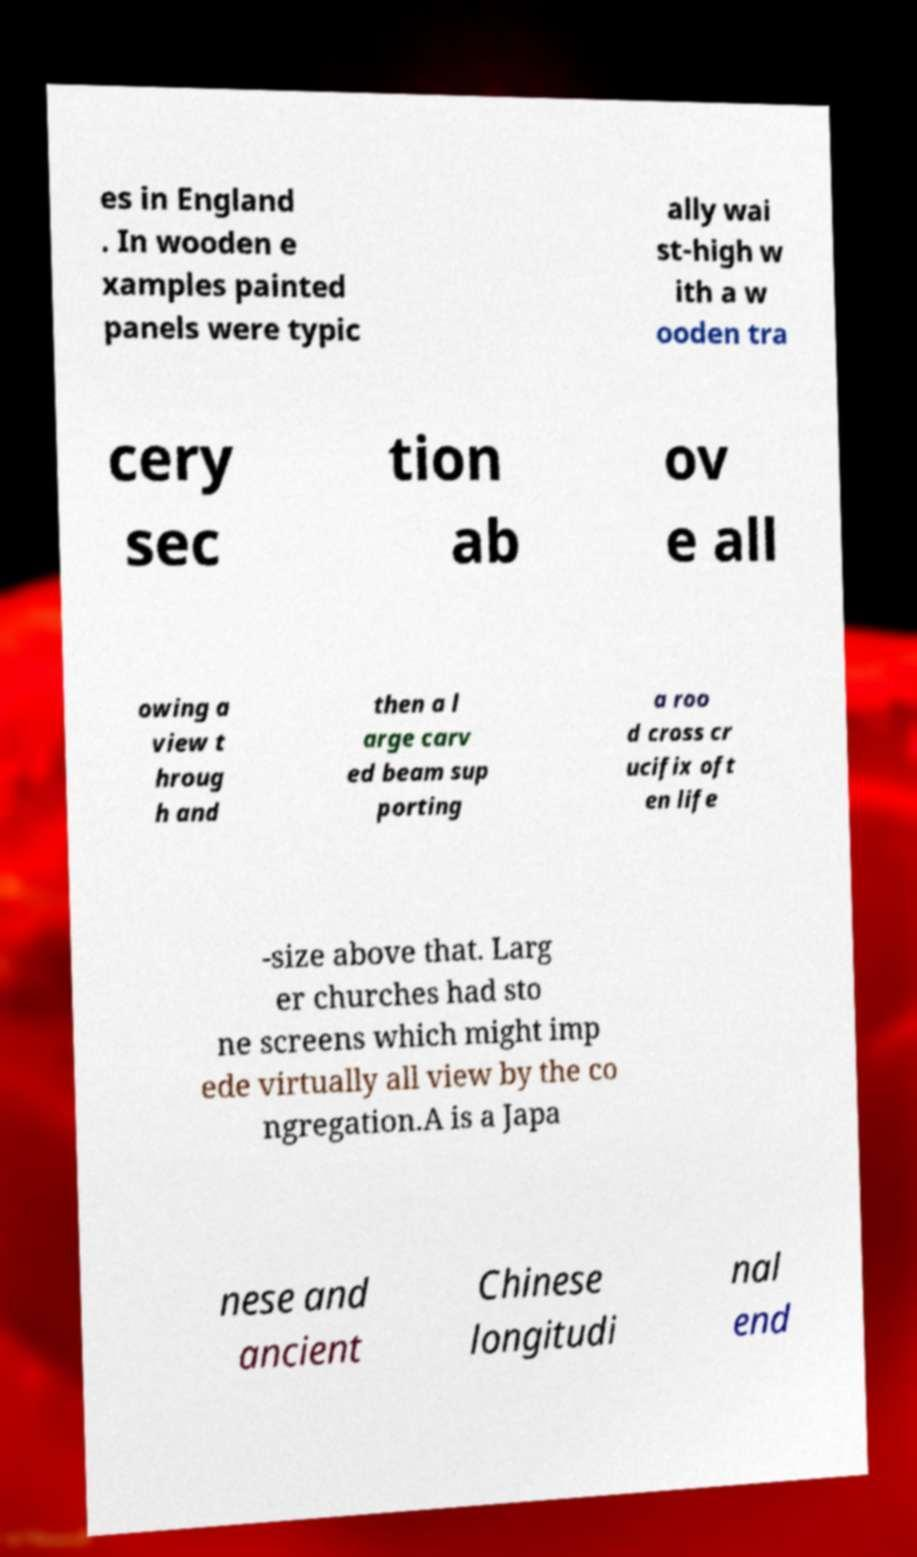Please read and relay the text visible in this image. What does it say? es in England . In wooden e xamples painted panels were typic ally wai st-high w ith a w ooden tra cery sec tion ab ov e all owing a view t hroug h and then a l arge carv ed beam sup porting a roo d cross cr ucifix oft en life -size above that. Larg er churches had sto ne screens which might imp ede virtually all view by the co ngregation.A is a Japa nese and ancient Chinese longitudi nal end 